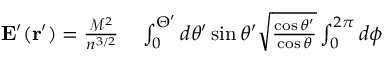<formula> <loc_0><loc_0><loc_500><loc_500>\begin{array} { r l } { E ^ { \prime } ( r ^ { \prime } ) = \frac { \mathcal { M } ^ { 2 } } { n ^ { 3 / 2 } } } & \int _ { 0 } ^ { \Theta ^ { \prime } } d \theta ^ { \prime } \sin \theta ^ { \prime } \sqrt { \frac { \cos \theta ^ { \prime } } { \cos \theta } } \int _ { 0 } ^ { 2 \pi } d \phi } \end{array}</formula> 